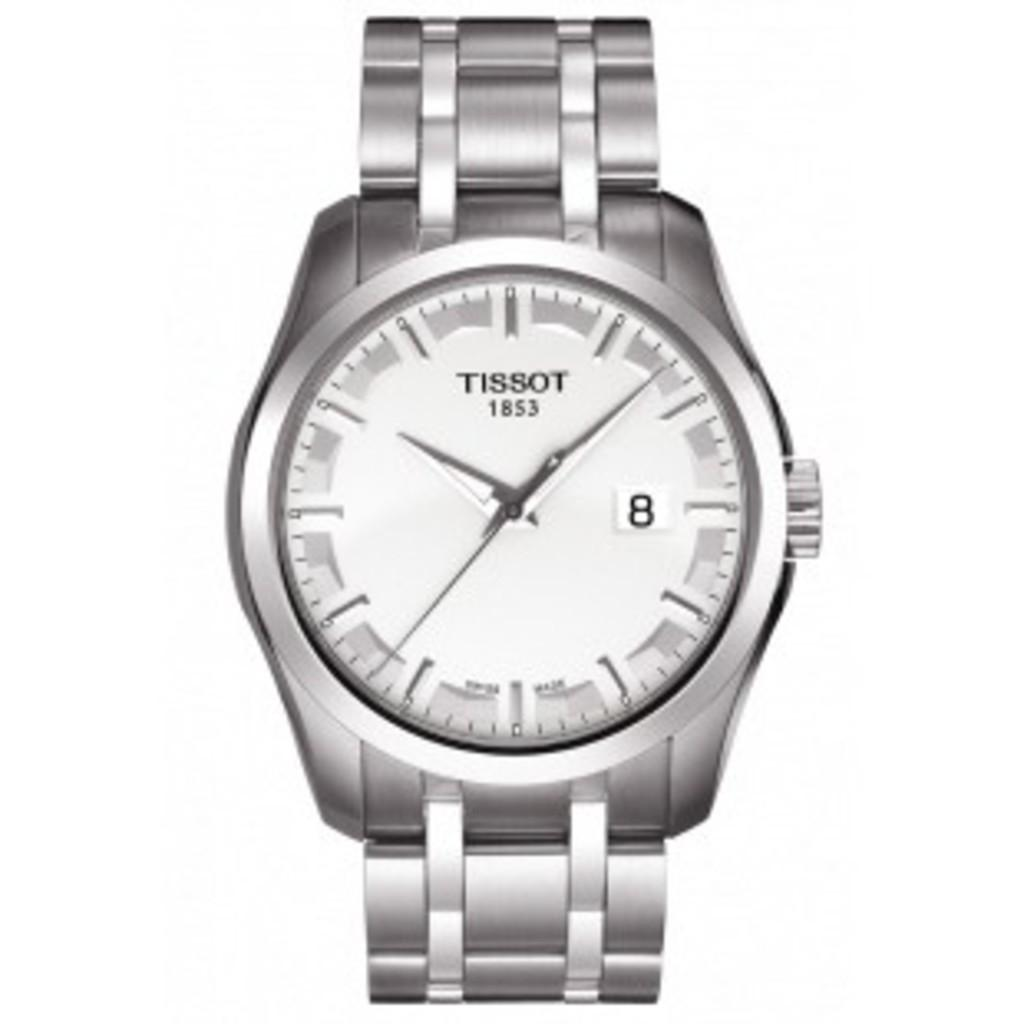<image>
Provide a brief description of the given image. A Tissot brand watch features the date 1853 on the face of the watch. 